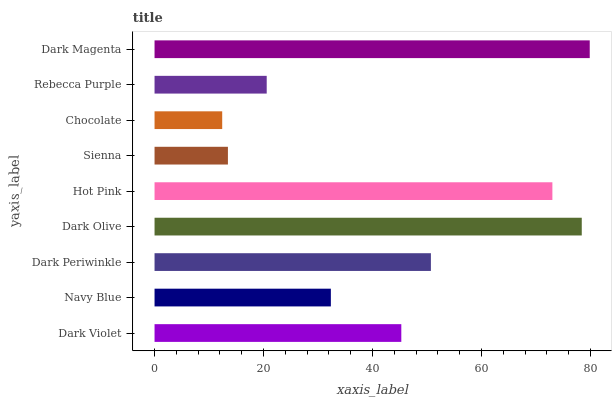Is Chocolate the minimum?
Answer yes or no. Yes. Is Dark Magenta the maximum?
Answer yes or no. Yes. Is Navy Blue the minimum?
Answer yes or no. No. Is Navy Blue the maximum?
Answer yes or no. No. Is Dark Violet greater than Navy Blue?
Answer yes or no. Yes. Is Navy Blue less than Dark Violet?
Answer yes or no. Yes. Is Navy Blue greater than Dark Violet?
Answer yes or no. No. Is Dark Violet less than Navy Blue?
Answer yes or no. No. Is Dark Violet the high median?
Answer yes or no. Yes. Is Dark Violet the low median?
Answer yes or no. Yes. Is Hot Pink the high median?
Answer yes or no. No. Is Sienna the low median?
Answer yes or no. No. 